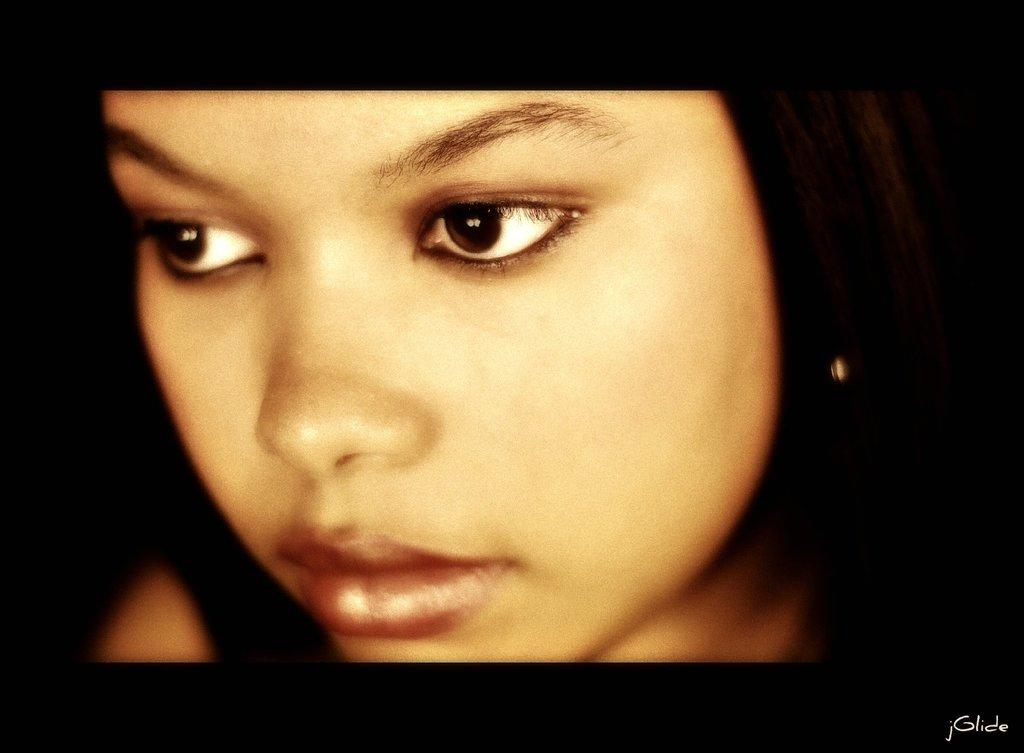What is the main subject of the image? The main subject of the image is the face of a person. How many snakes are wrapped around the person's face in the image? There are no snakes present in the image; it only features the face of a person. 